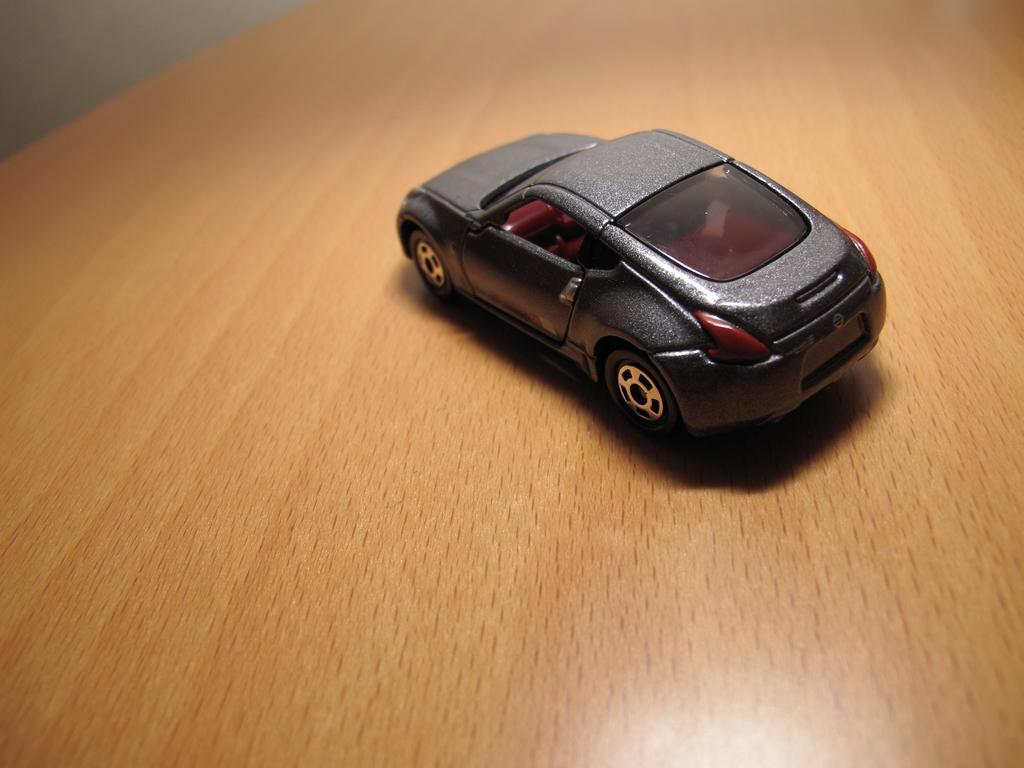Could you give a brief overview of what you see in this image? In the foreground of this image, there is a toy car on a wooden table and in the background, there is a wall. 